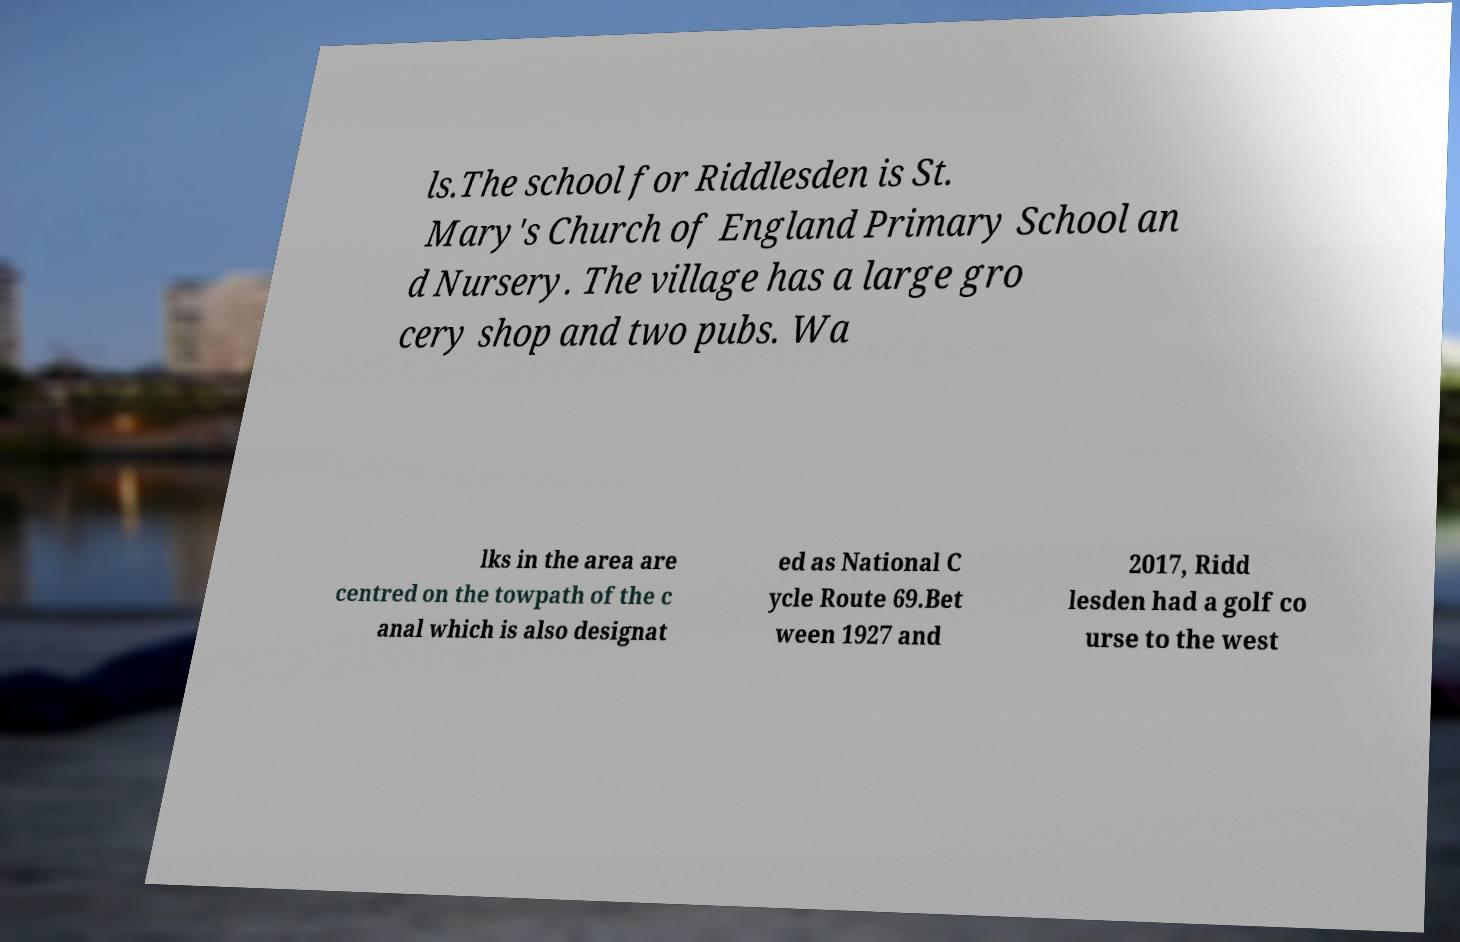Can you read and provide the text displayed in the image?This photo seems to have some interesting text. Can you extract and type it out for me? ls.The school for Riddlesden is St. Mary's Church of England Primary School an d Nursery. The village has a large gro cery shop and two pubs. Wa lks in the area are centred on the towpath of the c anal which is also designat ed as National C ycle Route 69.Bet ween 1927 and 2017, Ridd lesden had a golf co urse to the west 